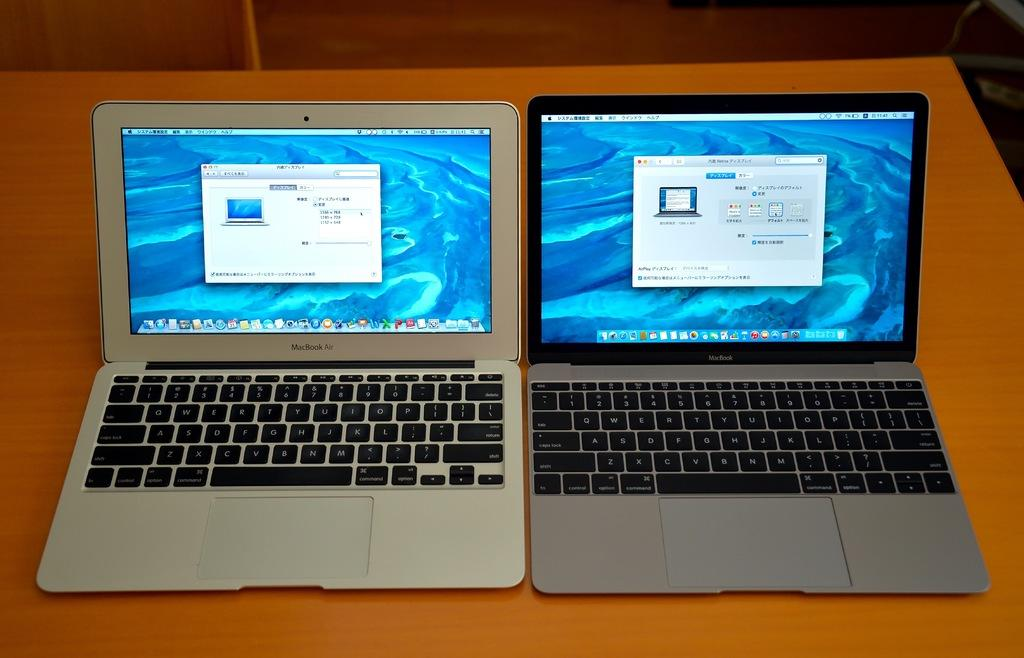<image>
Summarize the visual content of the image. Two laptop computers sitting side by side on a desk and both are macbooks. 